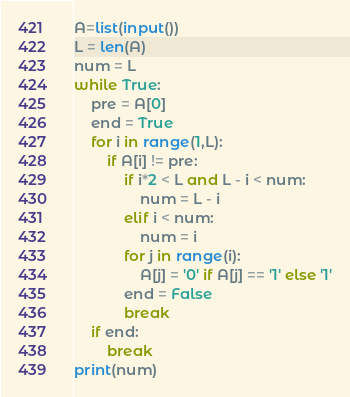Convert code to text. <code><loc_0><loc_0><loc_500><loc_500><_Python_>A=list(input())
L = len(A)
num = L
while True:
    pre = A[0]
    end = True
    for i in range(1,L):
        if A[i] != pre:
            if i*2 < L and L - i < num:
                num = L - i
            elif i < num:
                num = i
            for j in range(i):
                A[j] = '0' if A[j] == '1' else '1'
            end = False
            break
    if end:
        break
print(num)</code> 